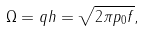Convert formula to latex. <formula><loc_0><loc_0><loc_500><loc_500>\Omega = q h = \sqrt { 2 \pi p _ { 0 } f } ,</formula> 